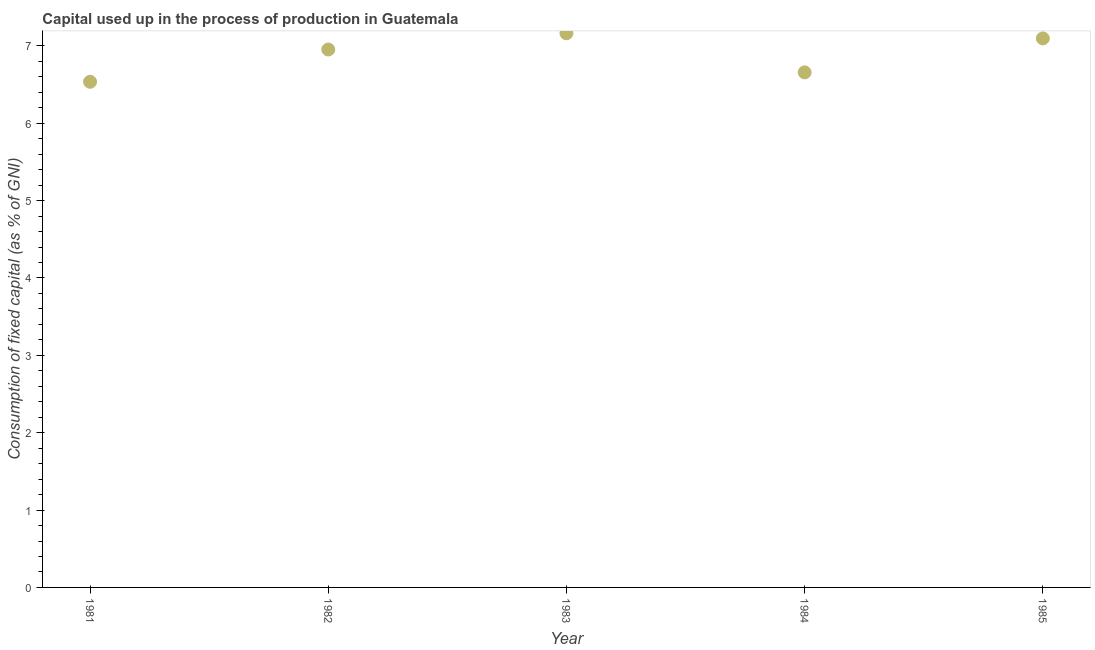What is the consumption of fixed capital in 1983?
Provide a succinct answer. 7.16. Across all years, what is the maximum consumption of fixed capital?
Provide a short and direct response. 7.16. Across all years, what is the minimum consumption of fixed capital?
Provide a succinct answer. 6.54. In which year was the consumption of fixed capital minimum?
Keep it short and to the point. 1981. What is the sum of the consumption of fixed capital?
Give a very brief answer. 34.4. What is the difference between the consumption of fixed capital in 1981 and 1985?
Provide a succinct answer. -0.56. What is the average consumption of fixed capital per year?
Offer a very short reply. 6.88. What is the median consumption of fixed capital?
Make the answer very short. 6.95. In how many years, is the consumption of fixed capital greater than 2.4 %?
Keep it short and to the point. 5. Do a majority of the years between 1982 and 1981 (inclusive) have consumption of fixed capital greater than 6.6 %?
Make the answer very short. No. What is the ratio of the consumption of fixed capital in 1982 to that in 1984?
Give a very brief answer. 1.04. Is the difference between the consumption of fixed capital in 1982 and 1983 greater than the difference between any two years?
Give a very brief answer. No. What is the difference between the highest and the second highest consumption of fixed capital?
Offer a very short reply. 0.07. What is the difference between the highest and the lowest consumption of fixed capital?
Your answer should be compact. 0.63. Does the consumption of fixed capital monotonically increase over the years?
Ensure brevity in your answer.  No. How many years are there in the graph?
Your answer should be very brief. 5. What is the difference between two consecutive major ticks on the Y-axis?
Keep it short and to the point. 1. Does the graph contain any zero values?
Give a very brief answer. No. Does the graph contain grids?
Provide a short and direct response. No. What is the title of the graph?
Offer a very short reply. Capital used up in the process of production in Guatemala. What is the label or title of the X-axis?
Provide a succinct answer. Year. What is the label or title of the Y-axis?
Ensure brevity in your answer.  Consumption of fixed capital (as % of GNI). What is the Consumption of fixed capital (as % of GNI) in 1981?
Keep it short and to the point. 6.54. What is the Consumption of fixed capital (as % of GNI) in 1982?
Provide a succinct answer. 6.95. What is the Consumption of fixed capital (as % of GNI) in 1983?
Offer a very short reply. 7.16. What is the Consumption of fixed capital (as % of GNI) in 1984?
Your answer should be very brief. 6.66. What is the Consumption of fixed capital (as % of GNI) in 1985?
Provide a succinct answer. 7.1. What is the difference between the Consumption of fixed capital (as % of GNI) in 1981 and 1982?
Your response must be concise. -0.42. What is the difference between the Consumption of fixed capital (as % of GNI) in 1981 and 1983?
Your answer should be compact. -0.63. What is the difference between the Consumption of fixed capital (as % of GNI) in 1981 and 1984?
Offer a very short reply. -0.12. What is the difference between the Consumption of fixed capital (as % of GNI) in 1981 and 1985?
Provide a succinct answer. -0.56. What is the difference between the Consumption of fixed capital (as % of GNI) in 1982 and 1983?
Make the answer very short. -0.21. What is the difference between the Consumption of fixed capital (as % of GNI) in 1982 and 1984?
Make the answer very short. 0.3. What is the difference between the Consumption of fixed capital (as % of GNI) in 1982 and 1985?
Provide a succinct answer. -0.14. What is the difference between the Consumption of fixed capital (as % of GNI) in 1983 and 1984?
Your answer should be compact. 0.51. What is the difference between the Consumption of fixed capital (as % of GNI) in 1983 and 1985?
Keep it short and to the point. 0.07. What is the difference between the Consumption of fixed capital (as % of GNI) in 1984 and 1985?
Make the answer very short. -0.44. What is the ratio of the Consumption of fixed capital (as % of GNI) in 1981 to that in 1983?
Offer a terse response. 0.91. What is the ratio of the Consumption of fixed capital (as % of GNI) in 1981 to that in 1985?
Keep it short and to the point. 0.92. What is the ratio of the Consumption of fixed capital (as % of GNI) in 1982 to that in 1984?
Your answer should be compact. 1.04. What is the ratio of the Consumption of fixed capital (as % of GNI) in 1982 to that in 1985?
Give a very brief answer. 0.98. What is the ratio of the Consumption of fixed capital (as % of GNI) in 1983 to that in 1984?
Make the answer very short. 1.08. What is the ratio of the Consumption of fixed capital (as % of GNI) in 1984 to that in 1985?
Make the answer very short. 0.94. 